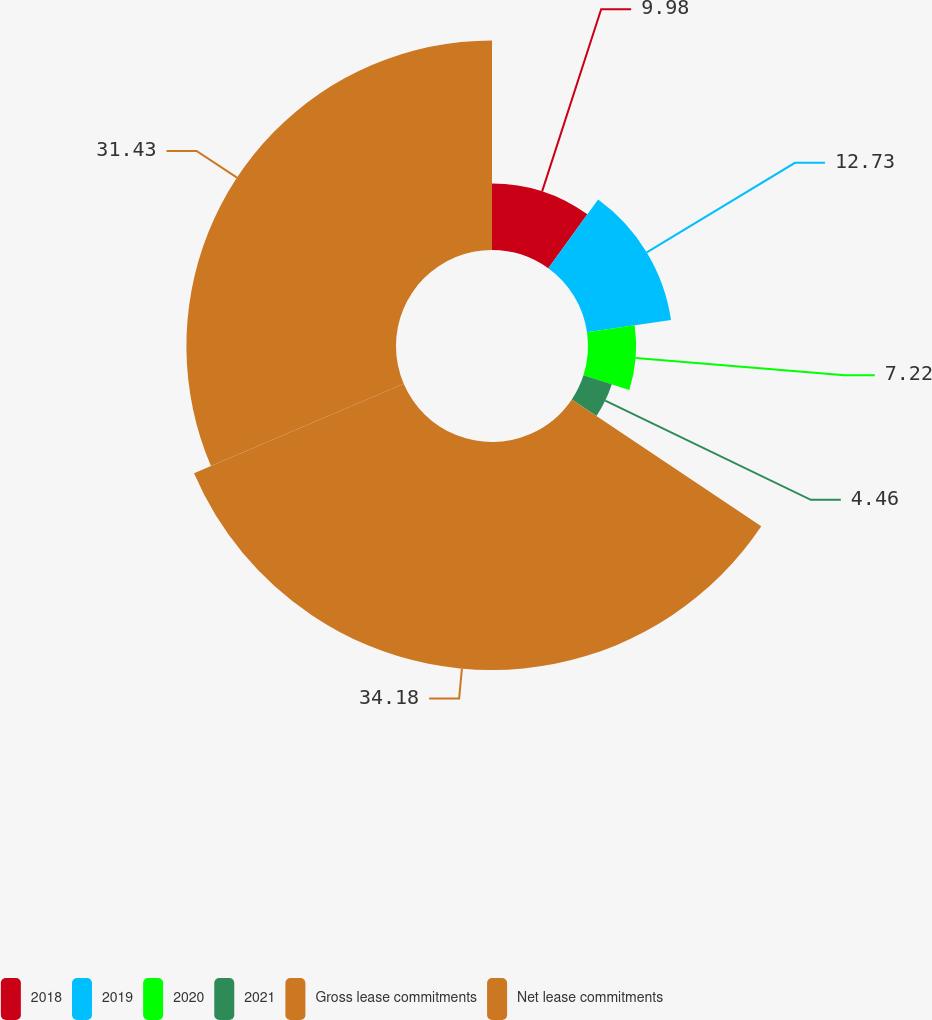Convert chart. <chart><loc_0><loc_0><loc_500><loc_500><pie_chart><fcel>2018<fcel>2019<fcel>2020<fcel>2021<fcel>Gross lease commitments<fcel>Net lease commitments<nl><fcel>9.98%<fcel>12.73%<fcel>7.22%<fcel>4.46%<fcel>34.19%<fcel>31.43%<nl></chart> 